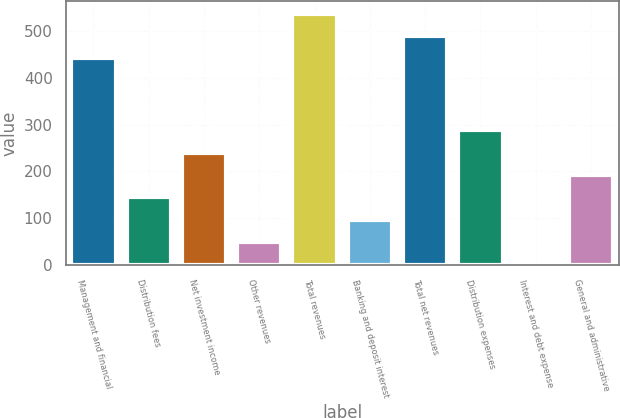Convert chart. <chart><loc_0><loc_0><loc_500><loc_500><bar_chart><fcel>Management and financial<fcel>Distribution fees<fcel>Net investment income<fcel>Other revenues<fcel>Total revenues<fcel>Banking and deposit interest<fcel>Total net revenues<fcel>Distribution expenses<fcel>Interest and debt expense<fcel>General and administrative<nl><fcel>441<fcel>144.4<fcel>240<fcel>48.8<fcel>536.6<fcel>96.6<fcel>488.8<fcel>287.8<fcel>1<fcel>192.2<nl></chart> 